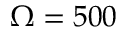Convert formula to latex. <formula><loc_0><loc_0><loc_500><loc_500>\Omega = 5 0 0</formula> 